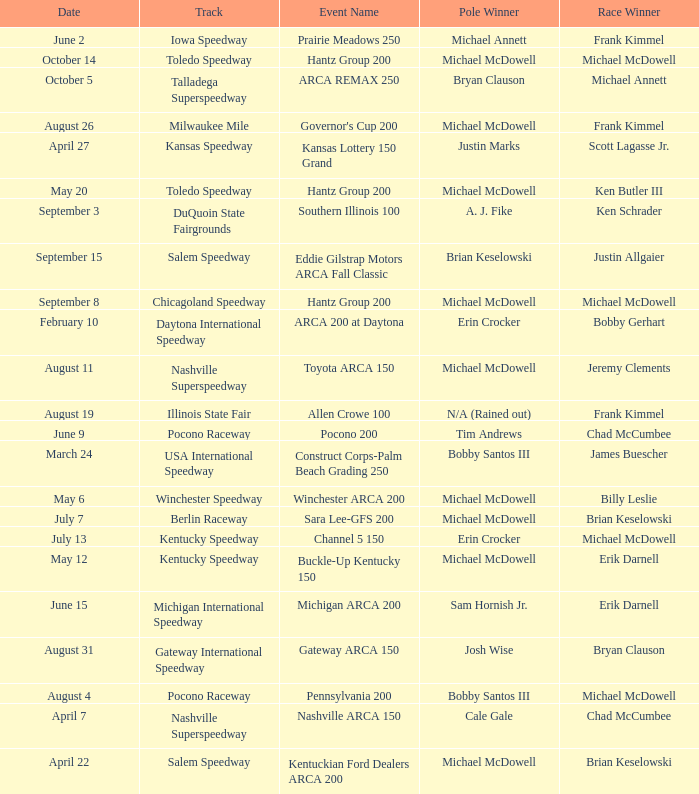Tell me the pole winner of may 12 Michael McDowell. I'm looking to parse the entire table for insights. Could you assist me with that? {'header': ['Date', 'Track', 'Event Name', 'Pole Winner', 'Race Winner'], 'rows': [['June 2', 'Iowa Speedway', 'Prairie Meadows 250', 'Michael Annett', 'Frank Kimmel'], ['October 14', 'Toledo Speedway', 'Hantz Group 200', 'Michael McDowell', 'Michael McDowell'], ['October 5', 'Talladega Superspeedway', 'ARCA REMAX 250', 'Bryan Clauson', 'Michael Annett'], ['August 26', 'Milwaukee Mile', "Governor's Cup 200", 'Michael McDowell', 'Frank Kimmel'], ['April 27', 'Kansas Speedway', 'Kansas Lottery 150 Grand', 'Justin Marks', 'Scott Lagasse Jr.'], ['May 20', 'Toledo Speedway', 'Hantz Group 200', 'Michael McDowell', 'Ken Butler III'], ['September 3', 'DuQuoin State Fairgrounds', 'Southern Illinois 100', 'A. J. Fike', 'Ken Schrader'], ['September 15', 'Salem Speedway', 'Eddie Gilstrap Motors ARCA Fall Classic', 'Brian Keselowski', 'Justin Allgaier'], ['September 8', 'Chicagoland Speedway', 'Hantz Group 200', 'Michael McDowell', 'Michael McDowell'], ['February 10', 'Daytona International Speedway', 'ARCA 200 at Daytona', 'Erin Crocker', 'Bobby Gerhart'], ['August 11', 'Nashville Superspeedway', 'Toyota ARCA 150', 'Michael McDowell', 'Jeremy Clements'], ['August 19', 'Illinois State Fair', 'Allen Crowe 100', 'N/A (Rained out)', 'Frank Kimmel'], ['June 9', 'Pocono Raceway', 'Pocono 200', 'Tim Andrews', 'Chad McCumbee'], ['March 24', 'USA International Speedway', 'Construct Corps-Palm Beach Grading 250', 'Bobby Santos III', 'James Buescher'], ['May 6', 'Winchester Speedway', 'Winchester ARCA 200', 'Michael McDowell', 'Billy Leslie'], ['July 7', 'Berlin Raceway', 'Sara Lee-GFS 200', 'Michael McDowell', 'Brian Keselowski'], ['July 13', 'Kentucky Speedway', 'Channel 5 150', 'Erin Crocker', 'Michael McDowell'], ['May 12', 'Kentucky Speedway', 'Buckle-Up Kentucky 150', 'Michael McDowell', 'Erik Darnell'], ['June 15', 'Michigan International Speedway', 'Michigan ARCA 200', 'Sam Hornish Jr.', 'Erik Darnell'], ['August 31', 'Gateway International Speedway', 'Gateway ARCA 150', 'Josh Wise', 'Bryan Clauson'], ['August 4', 'Pocono Raceway', 'Pennsylvania 200', 'Bobby Santos III', 'Michael McDowell'], ['April 7', 'Nashville Superspeedway', 'Nashville ARCA 150', 'Cale Gale', 'Chad McCumbee'], ['April 22', 'Salem Speedway', 'Kentuckian Ford Dealers ARCA 200', 'Michael McDowell', 'Brian Keselowski']]} 